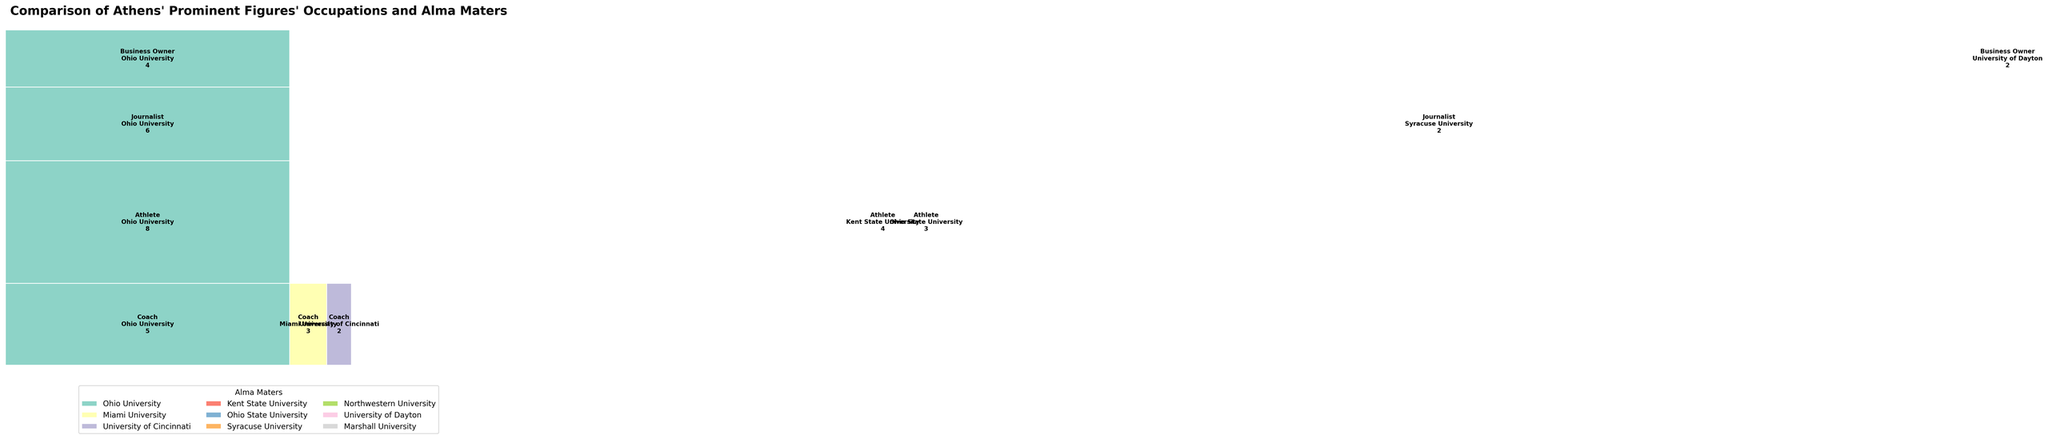What's the most common alma mater among all occupations? First, look at the rectangle sizes associated with each alma mater. Ohio University has rectangles consistently larger across multiple occupations. Specifically, they have the largest sections in Coach, Athlete, Journalist, and Business Owner categories, confirming it's the most common alma mater.
Answer: Ohio University Which occupation has the highest representation from Kent State University? Identify the rectangles colored for Kent State University among different occupations. The largest such rectangle belongs to the Athlete category.
Answer: Athlete How many journalists graduated from Ohio University? Refer to the Journalist section in the plot, and check the count written in the Ohio University rectangle. It states "6".
Answer: 6 Compare the number of Coaches from Miami University to the number of Business Owners from University of Dayton. Who has more representation? First, look at the counts within the Miami University section in Coaches which is "3". Next, look at the counts within the University of Dayton section in Business Owners which is "2".
Answer: Coaches from Miami University Which occupation is least represented from Northwestern University? Identify Northwestern University’s presence across the occupations. It appears only once in the Journalist section with a small area, representing the least presence overall.
Answer: Journalist How many more athletes graduated from Ohio University compared to Ohio State University? Find the counts for athletes from Ohio University and Ohio State University. Ohio University has 8, and Ohio State University has 3. Subtract the smaller from the larger: 8 - 3 = 5.
Answer: 5 Which occupation has contributions from all three alma maters: Ohio University, Miami University, and University of Cincinnati? Examine each occupation to find where all three universities are represented. Only the Coach category has sections (rectangles) from Ohio University, Miami University, and University of Cincinnati.
Answer: Coach What is the total number of business owners surveyed? Look at the sums of counts in the Business Owner category which includes Ohio University (4), University of Dayton (2), and Marshall University (1). Adding these together: 4 + 2 + 1 = 7.
Answer: 7 